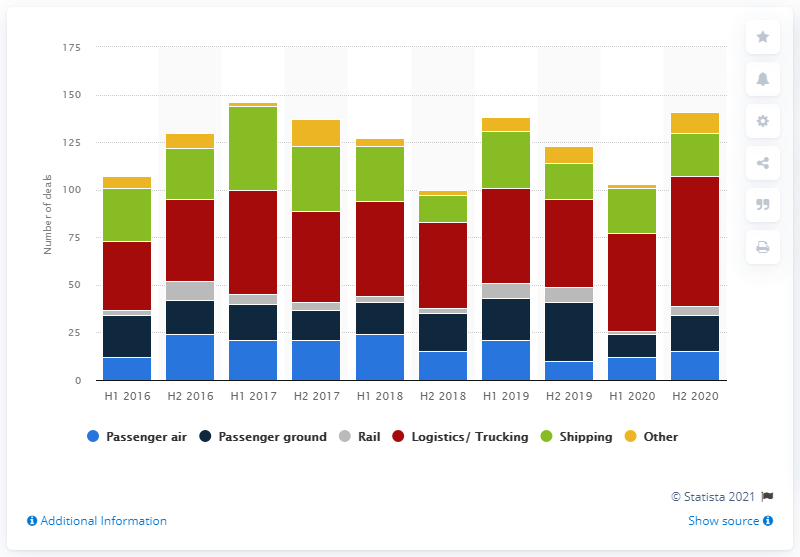List a handful of essential elements in this visual. In the last six months of 2020, a total of 68 deals were made in the logistics and trucking sector. 